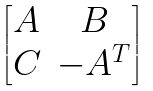<formula> <loc_0><loc_0><loc_500><loc_500>\begin{bmatrix} A & B \\ C & - A ^ { T } \end{bmatrix}</formula> 